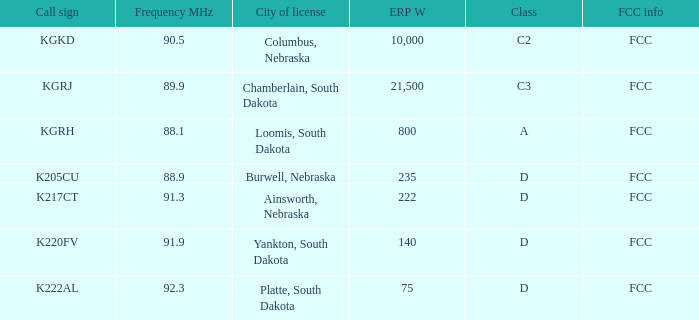Give me the full table as a dictionary. {'header': ['Call sign', 'Frequency MHz', 'City of license', 'ERP W', 'Class', 'FCC info'], 'rows': [['KGKD', '90.5', 'Columbus, Nebraska', '10,000', 'C2', 'FCC'], ['KGRJ', '89.9', 'Chamberlain, South Dakota', '21,500', 'C3', 'FCC'], ['KGRH', '88.1', 'Loomis, South Dakota', '800', 'A', 'FCC'], ['K205CU', '88.9', 'Burwell, Nebraska', '235', 'D', 'FCC'], ['K217CT', '91.3', 'Ainsworth, Nebraska', '222', 'D', 'FCC'], ['K220FV', '91.9', 'Yankton, South Dakota', '140', 'D', 'FCC'], ['K222AL', '92.3', 'Platte, South Dakota', '75', 'D', 'FCC']]} What is the sum of the erp w of the k222al call sign? 75.0. 